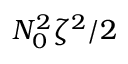<formula> <loc_0><loc_0><loc_500><loc_500>N _ { 0 } ^ { 2 } \zeta ^ { 2 } / 2</formula> 